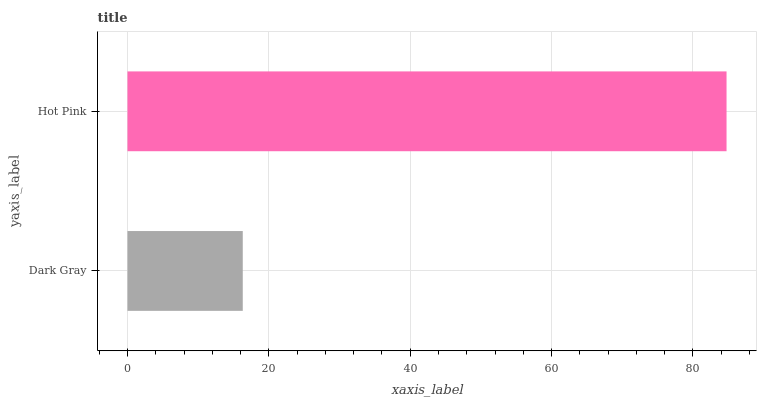Is Dark Gray the minimum?
Answer yes or no. Yes. Is Hot Pink the maximum?
Answer yes or no. Yes. Is Hot Pink the minimum?
Answer yes or no. No. Is Hot Pink greater than Dark Gray?
Answer yes or no. Yes. Is Dark Gray less than Hot Pink?
Answer yes or no. Yes. Is Dark Gray greater than Hot Pink?
Answer yes or no. No. Is Hot Pink less than Dark Gray?
Answer yes or no. No. Is Hot Pink the high median?
Answer yes or no. Yes. Is Dark Gray the low median?
Answer yes or no. Yes. Is Dark Gray the high median?
Answer yes or no. No. Is Hot Pink the low median?
Answer yes or no. No. 